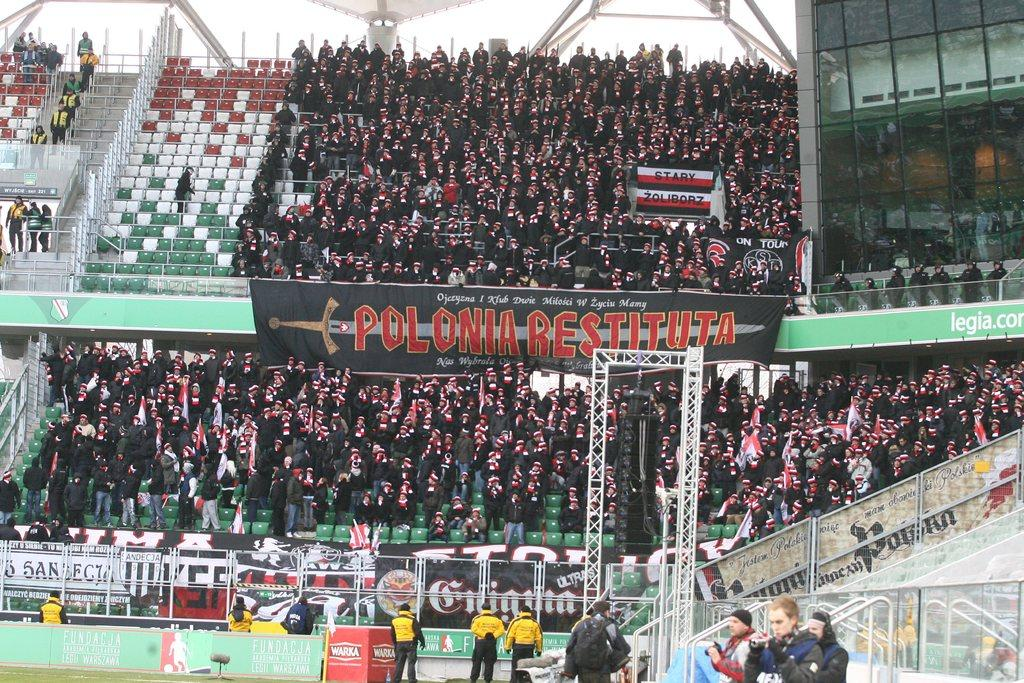What is the primary location of the people in the image? The people are standing on the ground in the image. What objects can be seen in the background of the image? There are chairs and people standing in the background of the image. What is the purpose of the board in the image? The board has some text on it, which suggests it might be used for communication or displaying information. What type of door can be seen in the image? There is no door present in the image. What time of day is it in the image, given the presence of a person? The time of day cannot be determined from the image, as there is no indication of lighting or shadows that would suggest a specific time. 